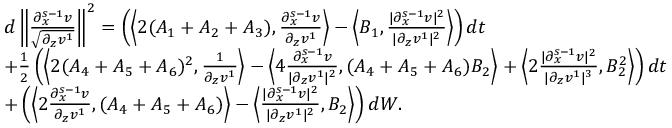Convert formula to latex. <formula><loc_0><loc_0><loc_500><loc_500>\begin{array} { r l } & { d \left \| \frac { \partial _ { x } ^ { s - 1 } v } { \sqrt { \partial _ { z } v ^ { 1 } } } \right \| ^ { 2 } = \left ( \left \langle 2 ( A _ { 1 } + A _ { 2 } + A _ { 3 } ) , \frac { \partial _ { x } ^ { s - 1 } v } { \partial _ { z } v ^ { 1 } } \right \rangle - \left \langle B _ { 1 } , \frac { | \partial _ { x } ^ { s - 1 } v | ^ { 2 } } { | \partial _ { z } v ^ { 1 } | ^ { 2 } } \right \rangle \right ) d t } \\ & { + \frac { 1 } { 2 } \left ( \left \langle 2 ( A _ { 4 } + A _ { 5 } + A _ { 6 } ) ^ { 2 } , \frac { 1 } \partial _ { z } v ^ { 1 } } \right \rangle - \left \langle 4 \frac { \partial _ { x } ^ { s - 1 } v } { | \partial _ { z } v ^ { 1 } | ^ { 2 } } , ( A _ { 4 } + A _ { 5 } + A _ { 6 } ) B _ { 2 } \right \rangle + \left \langle 2 \frac { | \partial _ { x } ^ { s - 1 } v | ^ { 2 } } { | \partial _ { z } v ^ { 1 } | ^ { 3 } } , B _ { 2 } ^ { 2 } \right \rangle \right ) d t } \\ & { + \left ( \left \langle 2 \frac { \partial _ { x } ^ { s - 1 } v } { \partial _ { z } v ^ { 1 } } , ( A _ { 4 } + A _ { 5 } + A _ { 6 } ) \right \rangle - \left \langle \frac { | \partial _ { x } ^ { s - 1 } v | ^ { 2 } } { | \partial _ { z } v ^ { 1 } | ^ { 2 } } , B _ { 2 } \right \rangle \right ) d W . } \end{array}</formula> 